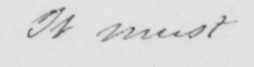Please transcribe the handwritten text in this image. it must 